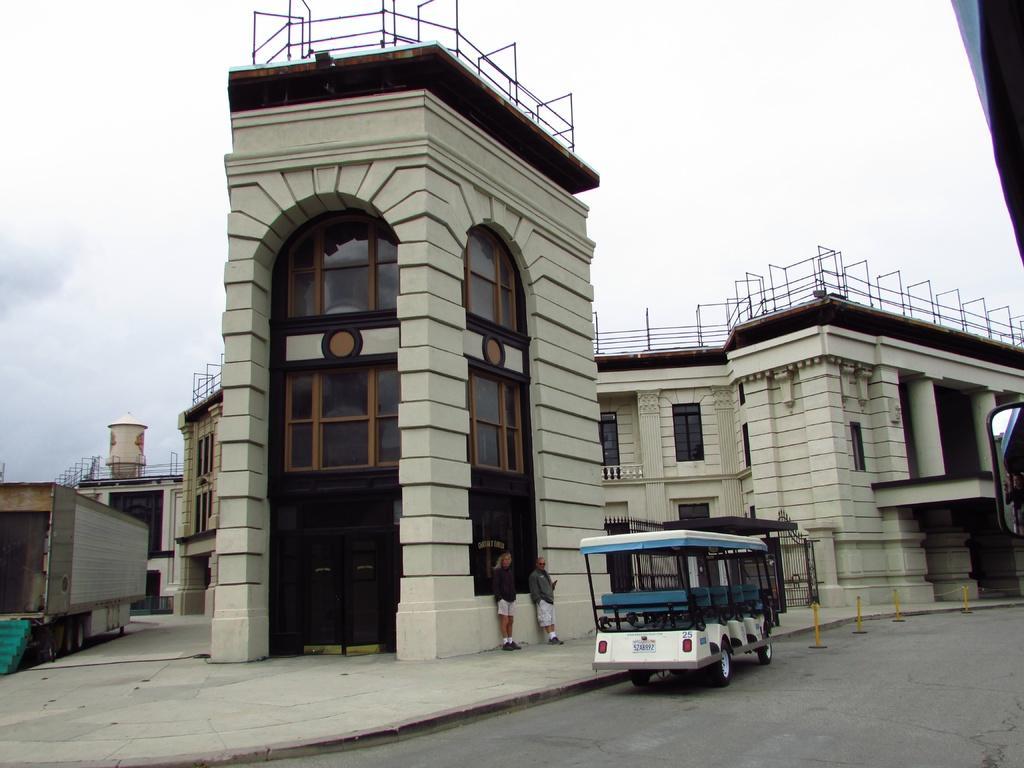Could you give a brief overview of what you see in this image? In this image in the center there is a vehicle on the road. In the background there are buildings and there are persons standing in the sky is cloudy. 